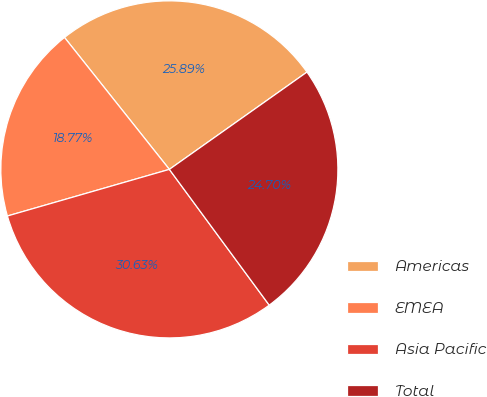Convert chart to OTSL. <chart><loc_0><loc_0><loc_500><loc_500><pie_chart><fcel>Americas<fcel>EMEA<fcel>Asia Pacific<fcel>Total<nl><fcel>25.89%<fcel>18.77%<fcel>30.63%<fcel>24.7%<nl></chart> 